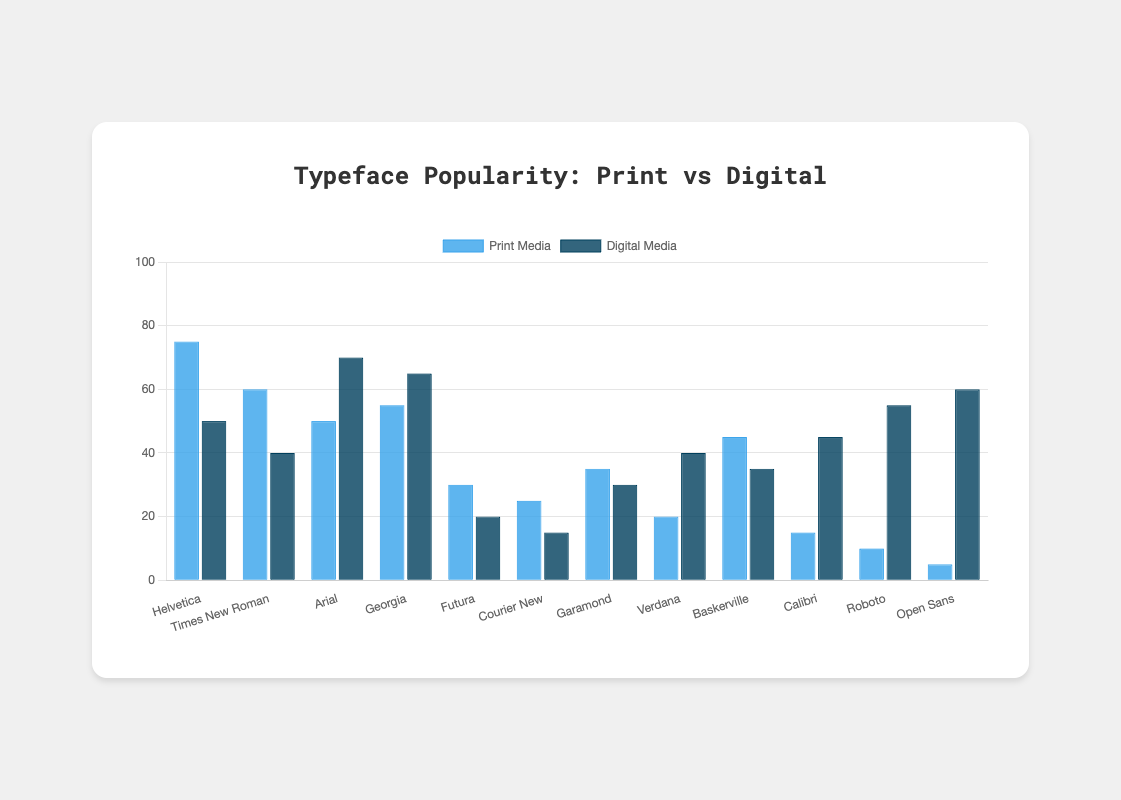Which typeface is the most popular in print media? By looking at the height of the bars, identify the typeface with the highest bar in the print media category.
Answer: Helvetica Which typeface is the least popular in digital media? By looking at the height of the bars, identify the typeface with the shortest bar in the digital media category.
Answer: Courier New How many typefaces have a higher popularity score in digital media compared to print media? Count the number of typefaces where the dark blue bar (digital media) is taller than the blue bar (print media). These typefaces are Arial, Georgia, Calibri, Roboto, and Open Sans.
Answer: 5 What is the total popularity score of Helvetica in both print and digital media? Add the values of Helvetica in print (75) and digital media (50). 75 + 50 = 125
Answer: 125 For which typefaces is print media more popular than digital media by at least 20 points? Find typefaces where the difference between the print media score and the digital media score is at least 20. These are Helvetica (75-50=25), Times New Roman (60-40=20), Futura (30-20=10), and Courier New (25-15=10). However, only Helvetica and Times New Roman meet the requirement.
Answer: Helvetica and Times New Roman What is the average popularity score for digital media across all typefaces? Sum the digital media scores (50 + 40 + 70 + 65 + 20 + 15 + 30 + 40 + 35 + 45 + 55 + 60) and divide by the number of typefaces (12). Total is 525; average is 525/12 = 43.75
Answer: 43.75 Which typeface has the greatest difference in popularity between print and digital media? Calculate the absolute difference between print and digital media scores for each typeface and identify the largest. Helvetica: 25, Times New Roman: 20, Arial: 20, Georgia: 10, Futura: 10, Courier New: 10, Garamond: 5, Verdana: 20, Baskerville: 10, Calibri: 30, Roboto: 45, Open Sans: 55. The greatest difference is for Open Sans (55).
Answer: Open Sans Are there any typefaces equally popular in print and digital media? Compare the print and digital media scores for equality. None of the typefaces have equal scores for both media.
Answer: No Which typeface has the second highest popularity score in digital media? Identify the typeface with the second highest dark blue bar height after the highest (which is Arial at 70). The second highest is Open Sans with 60.
Answer: Open Sans 